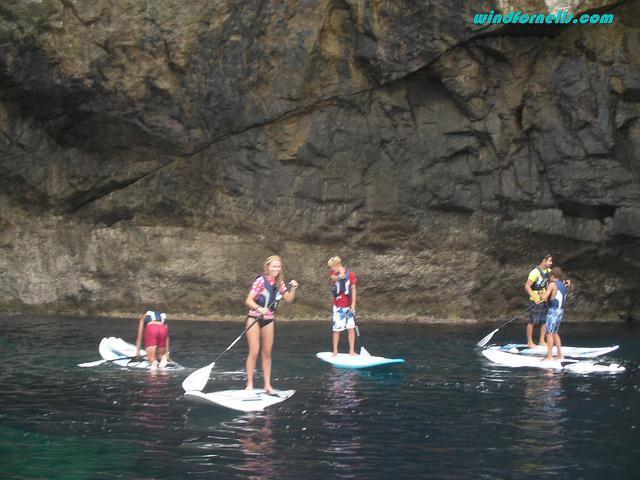How many people wearing backpacks are in the image?
Give a very brief answer. 0. 